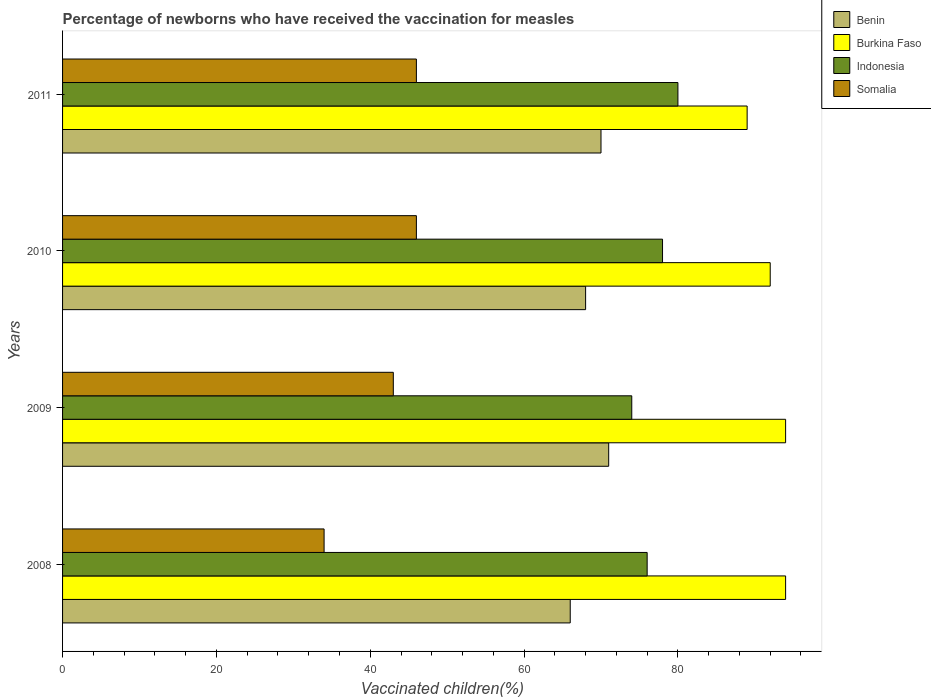How many different coloured bars are there?
Ensure brevity in your answer.  4. How many groups of bars are there?
Keep it short and to the point. 4. How many bars are there on the 2nd tick from the top?
Make the answer very short. 4. What is the label of the 2nd group of bars from the top?
Make the answer very short. 2010. What is the percentage of vaccinated children in Somalia in 2009?
Provide a succinct answer. 43. Across all years, what is the maximum percentage of vaccinated children in Somalia?
Offer a very short reply. 46. Across all years, what is the minimum percentage of vaccinated children in Somalia?
Keep it short and to the point. 34. What is the total percentage of vaccinated children in Indonesia in the graph?
Your response must be concise. 308. What is the difference between the percentage of vaccinated children in Benin in 2010 and that in 2011?
Give a very brief answer. -2. What is the average percentage of vaccinated children in Burkina Faso per year?
Offer a very short reply. 92.25. In how many years, is the percentage of vaccinated children in Burkina Faso greater than 32 %?
Keep it short and to the point. 4. What is the ratio of the percentage of vaccinated children in Benin in 2008 to that in 2010?
Keep it short and to the point. 0.97. What is the difference between the highest and the second highest percentage of vaccinated children in Benin?
Offer a very short reply. 1. Is it the case that in every year, the sum of the percentage of vaccinated children in Burkina Faso and percentage of vaccinated children in Somalia is greater than the sum of percentage of vaccinated children in Indonesia and percentage of vaccinated children in Benin?
Offer a terse response. No. What does the 1st bar from the top in 2010 represents?
Your answer should be compact. Somalia. What does the 1st bar from the bottom in 2009 represents?
Make the answer very short. Benin. How many bars are there?
Offer a terse response. 16. How many years are there in the graph?
Provide a succinct answer. 4. How many legend labels are there?
Provide a succinct answer. 4. How are the legend labels stacked?
Give a very brief answer. Vertical. What is the title of the graph?
Your answer should be very brief. Percentage of newborns who have received the vaccination for measles. Does "Dominican Republic" appear as one of the legend labels in the graph?
Offer a terse response. No. What is the label or title of the X-axis?
Your response must be concise. Vaccinated children(%). What is the label or title of the Y-axis?
Provide a succinct answer. Years. What is the Vaccinated children(%) of Benin in 2008?
Your answer should be compact. 66. What is the Vaccinated children(%) in Burkina Faso in 2008?
Provide a succinct answer. 94. What is the Vaccinated children(%) of Indonesia in 2008?
Provide a short and direct response. 76. What is the Vaccinated children(%) of Burkina Faso in 2009?
Your answer should be very brief. 94. What is the Vaccinated children(%) in Indonesia in 2009?
Provide a succinct answer. 74. What is the Vaccinated children(%) in Somalia in 2009?
Your answer should be compact. 43. What is the Vaccinated children(%) of Burkina Faso in 2010?
Offer a very short reply. 92. What is the Vaccinated children(%) of Benin in 2011?
Offer a terse response. 70. What is the Vaccinated children(%) in Burkina Faso in 2011?
Give a very brief answer. 89. What is the Vaccinated children(%) in Indonesia in 2011?
Your response must be concise. 80. Across all years, what is the maximum Vaccinated children(%) of Benin?
Offer a very short reply. 71. Across all years, what is the maximum Vaccinated children(%) in Burkina Faso?
Your response must be concise. 94. Across all years, what is the minimum Vaccinated children(%) in Burkina Faso?
Your answer should be very brief. 89. What is the total Vaccinated children(%) of Benin in the graph?
Offer a very short reply. 275. What is the total Vaccinated children(%) of Burkina Faso in the graph?
Give a very brief answer. 369. What is the total Vaccinated children(%) in Indonesia in the graph?
Make the answer very short. 308. What is the total Vaccinated children(%) of Somalia in the graph?
Your response must be concise. 169. What is the difference between the Vaccinated children(%) in Benin in 2008 and that in 2009?
Your response must be concise. -5. What is the difference between the Vaccinated children(%) of Indonesia in 2008 and that in 2009?
Make the answer very short. 2. What is the difference between the Vaccinated children(%) in Somalia in 2008 and that in 2009?
Give a very brief answer. -9. What is the difference between the Vaccinated children(%) in Benin in 2008 and that in 2010?
Keep it short and to the point. -2. What is the difference between the Vaccinated children(%) of Indonesia in 2008 and that in 2010?
Your answer should be very brief. -2. What is the difference between the Vaccinated children(%) of Benin in 2008 and that in 2011?
Provide a succinct answer. -4. What is the difference between the Vaccinated children(%) in Indonesia in 2008 and that in 2011?
Your response must be concise. -4. What is the difference between the Vaccinated children(%) in Benin in 2009 and that in 2010?
Offer a terse response. 3. What is the difference between the Vaccinated children(%) of Somalia in 2009 and that in 2010?
Keep it short and to the point. -3. What is the difference between the Vaccinated children(%) of Benin in 2009 and that in 2011?
Provide a succinct answer. 1. What is the difference between the Vaccinated children(%) of Burkina Faso in 2009 and that in 2011?
Make the answer very short. 5. What is the difference between the Vaccinated children(%) of Indonesia in 2009 and that in 2011?
Your answer should be compact. -6. What is the difference between the Vaccinated children(%) of Benin in 2010 and that in 2011?
Make the answer very short. -2. What is the difference between the Vaccinated children(%) in Burkina Faso in 2010 and that in 2011?
Your response must be concise. 3. What is the difference between the Vaccinated children(%) of Indonesia in 2010 and that in 2011?
Offer a very short reply. -2. What is the difference between the Vaccinated children(%) of Benin in 2008 and the Vaccinated children(%) of Somalia in 2009?
Your response must be concise. 23. What is the difference between the Vaccinated children(%) in Indonesia in 2008 and the Vaccinated children(%) in Somalia in 2009?
Keep it short and to the point. 33. What is the difference between the Vaccinated children(%) in Benin in 2008 and the Vaccinated children(%) in Burkina Faso in 2010?
Ensure brevity in your answer.  -26. What is the difference between the Vaccinated children(%) in Burkina Faso in 2008 and the Vaccinated children(%) in Somalia in 2010?
Your response must be concise. 48. What is the difference between the Vaccinated children(%) in Indonesia in 2008 and the Vaccinated children(%) in Somalia in 2010?
Your answer should be very brief. 30. What is the difference between the Vaccinated children(%) of Benin in 2008 and the Vaccinated children(%) of Burkina Faso in 2011?
Give a very brief answer. -23. What is the difference between the Vaccinated children(%) of Benin in 2008 and the Vaccinated children(%) of Indonesia in 2011?
Your answer should be compact. -14. What is the difference between the Vaccinated children(%) of Benin in 2008 and the Vaccinated children(%) of Somalia in 2011?
Make the answer very short. 20. What is the difference between the Vaccinated children(%) in Burkina Faso in 2008 and the Vaccinated children(%) in Indonesia in 2011?
Keep it short and to the point. 14. What is the difference between the Vaccinated children(%) of Burkina Faso in 2008 and the Vaccinated children(%) of Somalia in 2011?
Make the answer very short. 48. What is the difference between the Vaccinated children(%) in Benin in 2009 and the Vaccinated children(%) in Somalia in 2010?
Give a very brief answer. 25. What is the difference between the Vaccinated children(%) in Burkina Faso in 2009 and the Vaccinated children(%) in Indonesia in 2010?
Offer a very short reply. 16. What is the difference between the Vaccinated children(%) of Burkina Faso in 2009 and the Vaccinated children(%) of Somalia in 2010?
Offer a terse response. 48. What is the difference between the Vaccinated children(%) in Burkina Faso in 2009 and the Vaccinated children(%) in Somalia in 2011?
Keep it short and to the point. 48. What is the difference between the Vaccinated children(%) in Indonesia in 2009 and the Vaccinated children(%) in Somalia in 2011?
Provide a succinct answer. 28. What is the difference between the Vaccinated children(%) of Benin in 2010 and the Vaccinated children(%) of Somalia in 2011?
Ensure brevity in your answer.  22. What is the difference between the Vaccinated children(%) of Burkina Faso in 2010 and the Vaccinated children(%) of Indonesia in 2011?
Offer a terse response. 12. What is the average Vaccinated children(%) in Benin per year?
Provide a short and direct response. 68.75. What is the average Vaccinated children(%) of Burkina Faso per year?
Your answer should be very brief. 92.25. What is the average Vaccinated children(%) of Indonesia per year?
Ensure brevity in your answer.  77. What is the average Vaccinated children(%) of Somalia per year?
Offer a very short reply. 42.25. In the year 2008, what is the difference between the Vaccinated children(%) in Benin and Vaccinated children(%) in Burkina Faso?
Your answer should be very brief. -28. In the year 2008, what is the difference between the Vaccinated children(%) of Burkina Faso and Vaccinated children(%) of Indonesia?
Make the answer very short. 18. In the year 2009, what is the difference between the Vaccinated children(%) of Benin and Vaccinated children(%) of Indonesia?
Offer a terse response. -3. In the year 2009, what is the difference between the Vaccinated children(%) in Burkina Faso and Vaccinated children(%) in Indonesia?
Make the answer very short. 20. In the year 2010, what is the difference between the Vaccinated children(%) of Burkina Faso and Vaccinated children(%) of Indonesia?
Give a very brief answer. 14. In the year 2010, what is the difference between the Vaccinated children(%) in Burkina Faso and Vaccinated children(%) in Somalia?
Provide a short and direct response. 46. In the year 2010, what is the difference between the Vaccinated children(%) in Indonesia and Vaccinated children(%) in Somalia?
Your answer should be compact. 32. In the year 2011, what is the difference between the Vaccinated children(%) of Benin and Vaccinated children(%) of Burkina Faso?
Provide a succinct answer. -19. In the year 2011, what is the difference between the Vaccinated children(%) of Burkina Faso and Vaccinated children(%) of Indonesia?
Keep it short and to the point. 9. In the year 2011, what is the difference between the Vaccinated children(%) of Burkina Faso and Vaccinated children(%) of Somalia?
Your response must be concise. 43. What is the ratio of the Vaccinated children(%) of Benin in 2008 to that in 2009?
Make the answer very short. 0.93. What is the ratio of the Vaccinated children(%) in Burkina Faso in 2008 to that in 2009?
Offer a terse response. 1. What is the ratio of the Vaccinated children(%) in Somalia in 2008 to that in 2009?
Provide a succinct answer. 0.79. What is the ratio of the Vaccinated children(%) of Benin in 2008 to that in 2010?
Offer a terse response. 0.97. What is the ratio of the Vaccinated children(%) of Burkina Faso in 2008 to that in 2010?
Offer a very short reply. 1.02. What is the ratio of the Vaccinated children(%) of Indonesia in 2008 to that in 2010?
Offer a terse response. 0.97. What is the ratio of the Vaccinated children(%) of Somalia in 2008 to that in 2010?
Offer a terse response. 0.74. What is the ratio of the Vaccinated children(%) of Benin in 2008 to that in 2011?
Provide a succinct answer. 0.94. What is the ratio of the Vaccinated children(%) of Burkina Faso in 2008 to that in 2011?
Make the answer very short. 1.06. What is the ratio of the Vaccinated children(%) in Indonesia in 2008 to that in 2011?
Your answer should be very brief. 0.95. What is the ratio of the Vaccinated children(%) in Somalia in 2008 to that in 2011?
Provide a succinct answer. 0.74. What is the ratio of the Vaccinated children(%) of Benin in 2009 to that in 2010?
Your response must be concise. 1.04. What is the ratio of the Vaccinated children(%) of Burkina Faso in 2009 to that in 2010?
Offer a terse response. 1.02. What is the ratio of the Vaccinated children(%) in Indonesia in 2009 to that in 2010?
Your answer should be compact. 0.95. What is the ratio of the Vaccinated children(%) in Somalia in 2009 to that in 2010?
Give a very brief answer. 0.93. What is the ratio of the Vaccinated children(%) of Benin in 2009 to that in 2011?
Your answer should be compact. 1.01. What is the ratio of the Vaccinated children(%) of Burkina Faso in 2009 to that in 2011?
Offer a very short reply. 1.06. What is the ratio of the Vaccinated children(%) of Indonesia in 2009 to that in 2011?
Make the answer very short. 0.93. What is the ratio of the Vaccinated children(%) of Somalia in 2009 to that in 2011?
Your answer should be compact. 0.93. What is the ratio of the Vaccinated children(%) in Benin in 2010 to that in 2011?
Your answer should be compact. 0.97. What is the ratio of the Vaccinated children(%) in Burkina Faso in 2010 to that in 2011?
Your response must be concise. 1.03. What is the ratio of the Vaccinated children(%) in Indonesia in 2010 to that in 2011?
Offer a terse response. 0.97. What is the difference between the highest and the second highest Vaccinated children(%) of Indonesia?
Your answer should be compact. 2. What is the difference between the highest and the lowest Vaccinated children(%) in Somalia?
Keep it short and to the point. 12. 